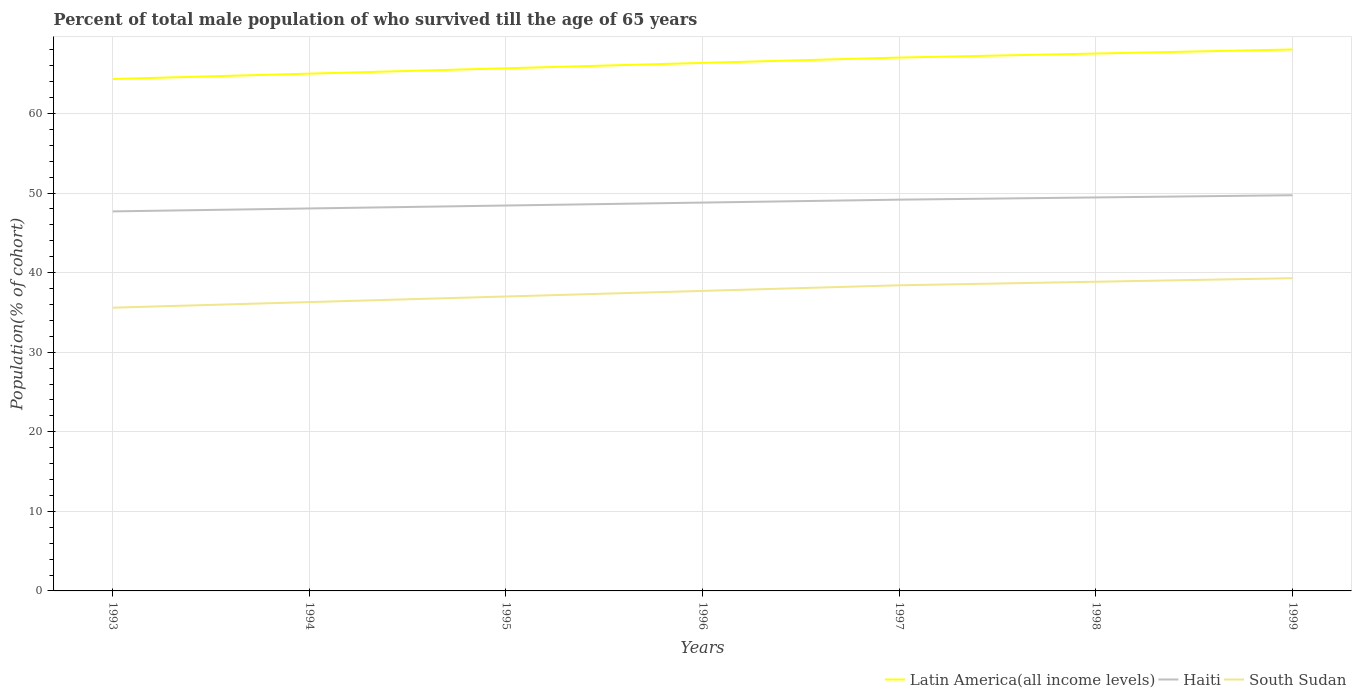How many different coloured lines are there?
Your response must be concise. 3. Across all years, what is the maximum percentage of total male population who survived till the age of 65 years in South Sudan?
Provide a short and direct response. 35.59. In which year was the percentage of total male population who survived till the age of 65 years in South Sudan maximum?
Provide a short and direct response. 1993. What is the total percentage of total male population who survived till the age of 65 years in Haiti in the graph?
Keep it short and to the point. -0.74. What is the difference between the highest and the second highest percentage of total male population who survived till the age of 65 years in Latin America(all income levels)?
Your answer should be very brief. 3.71. What is the difference between the highest and the lowest percentage of total male population who survived till the age of 65 years in Haiti?
Provide a short and direct response. 4. How many lines are there?
Provide a succinct answer. 3. Does the graph contain any zero values?
Your answer should be very brief. No. Does the graph contain grids?
Offer a terse response. Yes. How many legend labels are there?
Provide a succinct answer. 3. How are the legend labels stacked?
Provide a short and direct response. Horizontal. What is the title of the graph?
Your answer should be compact. Percent of total male population of who survived till the age of 65 years. What is the label or title of the X-axis?
Provide a succinct answer. Years. What is the label or title of the Y-axis?
Provide a short and direct response. Population(% of cohort). What is the Population(% of cohort) in Latin America(all income levels) in 1993?
Make the answer very short. 64.33. What is the Population(% of cohort) of Haiti in 1993?
Your response must be concise. 47.69. What is the Population(% of cohort) of South Sudan in 1993?
Ensure brevity in your answer.  35.59. What is the Population(% of cohort) of Latin America(all income levels) in 1994?
Make the answer very short. 65.01. What is the Population(% of cohort) of Haiti in 1994?
Ensure brevity in your answer.  48.06. What is the Population(% of cohort) of South Sudan in 1994?
Your response must be concise. 36.3. What is the Population(% of cohort) of Latin America(all income levels) in 1995?
Provide a short and direct response. 65.68. What is the Population(% of cohort) of Haiti in 1995?
Your answer should be compact. 48.43. What is the Population(% of cohort) in South Sudan in 1995?
Keep it short and to the point. 37. What is the Population(% of cohort) of Latin America(all income levels) in 1996?
Your answer should be compact. 66.35. What is the Population(% of cohort) of Haiti in 1996?
Make the answer very short. 48.8. What is the Population(% of cohort) in South Sudan in 1996?
Ensure brevity in your answer.  37.7. What is the Population(% of cohort) in Latin America(all income levels) in 1997?
Your answer should be compact. 67.02. What is the Population(% of cohort) of Haiti in 1997?
Offer a very short reply. 49.17. What is the Population(% of cohort) in South Sudan in 1997?
Offer a very short reply. 38.41. What is the Population(% of cohort) in Latin America(all income levels) in 1998?
Provide a short and direct response. 67.53. What is the Population(% of cohort) in Haiti in 1998?
Make the answer very short. 49.45. What is the Population(% of cohort) of South Sudan in 1998?
Provide a short and direct response. 38.85. What is the Population(% of cohort) of Latin America(all income levels) in 1999?
Provide a succinct answer. 68.04. What is the Population(% of cohort) in Haiti in 1999?
Ensure brevity in your answer.  49.73. What is the Population(% of cohort) in South Sudan in 1999?
Your answer should be very brief. 39.3. Across all years, what is the maximum Population(% of cohort) in Latin America(all income levels)?
Make the answer very short. 68.04. Across all years, what is the maximum Population(% of cohort) in Haiti?
Your response must be concise. 49.73. Across all years, what is the maximum Population(% of cohort) in South Sudan?
Keep it short and to the point. 39.3. Across all years, what is the minimum Population(% of cohort) in Latin America(all income levels)?
Offer a very short reply. 64.33. Across all years, what is the minimum Population(% of cohort) in Haiti?
Provide a succinct answer. 47.69. Across all years, what is the minimum Population(% of cohort) in South Sudan?
Offer a terse response. 35.59. What is the total Population(% of cohort) of Latin America(all income levels) in the graph?
Provide a succinct answer. 463.97. What is the total Population(% of cohort) in Haiti in the graph?
Offer a terse response. 341.34. What is the total Population(% of cohort) of South Sudan in the graph?
Your response must be concise. 263.16. What is the difference between the Population(% of cohort) of Latin America(all income levels) in 1993 and that in 1994?
Give a very brief answer. -0.68. What is the difference between the Population(% of cohort) in Haiti in 1993 and that in 1994?
Give a very brief answer. -0.37. What is the difference between the Population(% of cohort) of South Sudan in 1993 and that in 1994?
Your response must be concise. -0.7. What is the difference between the Population(% of cohort) of Latin America(all income levels) in 1993 and that in 1995?
Your response must be concise. -1.35. What is the difference between the Population(% of cohort) in Haiti in 1993 and that in 1995?
Your response must be concise. -0.74. What is the difference between the Population(% of cohort) in South Sudan in 1993 and that in 1995?
Provide a short and direct response. -1.41. What is the difference between the Population(% of cohort) in Latin America(all income levels) in 1993 and that in 1996?
Your answer should be very brief. -2.02. What is the difference between the Population(% of cohort) of Haiti in 1993 and that in 1996?
Provide a succinct answer. -1.11. What is the difference between the Population(% of cohort) in South Sudan in 1993 and that in 1996?
Your answer should be very brief. -2.11. What is the difference between the Population(% of cohort) in Latin America(all income levels) in 1993 and that in 1997?
Provide a succinct answer. -2.7. What is the difference between the Population(% of cohort) of Haiti in 1993 and that in 1997?
Keep it short and to the point. -1.48. What is the difference between the Population(% of cohort) in South Sudan in 1993 and that in 1997?
Provide a succinct answer. -2.81. What is the difference between the Population(% of cohort) of Latin America(all income levels) in 1993 and that in 1998?
Make the answer very short. -3.2. What is the difference between the Population(% of cohort) in Haiti in 1993 and that in 1998?
Offer a very short reply. -1.75. What is the difference between the Population(% of cohort) of South Sudan in 1993 and that in 1998?
Make the answer very short. -3.26. What is the difference between the Population(% of cohort) of Latin America(all income levels) in 1993 and that in 1999?
Your answer should be compact. -3.71. What is the difference between the Population(% of cohort) of Haiti in 1993 and that in 1999?
Give a very brief answer. -2.03. What is the difference between the Population(% of cohort) of South Sudan in 1993 and that in 1999?
Offer a terse response. -3.71. What is the difference between the Population(% of cohort) in Latin America(all income levels) in 1994 and that in 1995?
Your answer should be compact. -0.67. What is the difference between the Population(% of cohort) of Haiti in 1994 and that in 1995?
Provide a succinct answer. -0.37. What is the difference between the Population(% of cohort) of South Sudan in 1994 and that in 1995?
Your response must be concise. -0.7. What is the difference between the Population(% of cohort) in Latin America(all income levels) in 1994 and that in 1996?
Provide a succinct answer. -1.35. What is the difference between the Population(% of cohort) in Haiti in 1994 and that in 1996?
Your answer should be very brief. -0.74. What is the difference between the Population(% of cohort) of South Sudan in 1994 and that in 1996?
Your response must be concise. -1.41. What is the difference between the Population(% of cohort) of Latin America(all income levels) in 1994 and that in 1997?
Your answer should be very brief. -2.02. What is the difference between the Population(% of cohort) of Haiti in 1994 and that in 1997?
Ensure brevity in your answer.  -1.11. What is the difference between the Population(% of cohort) of South Sudan in 1994 and that in 1997?
Keep it short and to the point. -2.11. What is the difference between the Population(% of cohort) of Latin America(all income levels) in 1994 and that in 1998?
Offer a very short reply. -2.53. What is the difference between the Population(% of cohort) of Haiti in 1994 and that in 1998?
Your response must be concise. -1.38. What is the difference between the Population(% of cohort) of South Sudan in 1994 and that in 1998?
Your answer should be compact. -2.56. What is the difference between the Population(% of cohort) of Latin America(all income levels) in 1994 and that in 1999?
Provide a succinct answer. -3.03. What is the difference between the Population(% of cohort) in Haiti in 1994 and that in 1999?
Offer a terse response. -1.66. What is the difference between the Population(% of cohort) of South Sudan in 1994 and that in 1999?
Your response must be concise. -3. What is the difference between the Population(% of cohort) of Latin America(all income levels) in 1995 and that in 1996?
Your answer should be very brief. -0.67. What is the difference between the Population(% of cohort) of Haiti in 1995 and that in 1996?
Your answer should be compact. -0.37. What is the difference between the Population(% of cohort) in South Sudan in 1995 and that in 1996?
Your response must be concise. -0.7. What is the difference between the Population(% of cohort) in Latin America(all income levels) in 1995 and that in 1997?
Offer a very short reply. -1.35. What is the difference between the Population(% of cohort) in Haiti in 1995 and that in 1997?
Your response must be concise. -0.74. What is the difference between the Population(% of cohort) of South Sudan in 1995 and that in 1997?
Give a very brief answer. -1.41. What is the difference between the Population(% of cohort) in Latin America(all income levels) in 1995 and that in 1998?
Offer a very short reply. -1.85. What is the difference between the Population(% of cohort) in Haiti in 1995 and that in 1998?
Keep it short and to the point. -1.02. What is the difference between the Population(% of cohort) of South Sudan in 1995 and that in 1998?
Make the answer very short. -1.85. What is the difference between the Population(% of cohort) of Latin America(all income levels) in 1995 and that in 1999?
Provide a succinct answer. -2.36. What is the difference between the Population(% of cohort) of Haiti in 1995 and that in 1999?
Give a very brief answer. -1.29. What is the difference between the Population(% of cohort) of South Sudan in 1995 and that in 1999?
Keep it short and to the point. -2.3. What is the difference between the Population(% of cohort) in Latin America(all income levels) in 1996 and that in 1997?
Provide a succinct answer. -0.67. What is the difference between the Population(% of cohort) of Haiti in 1996 and that in 1997?
Offer a very short reply. -0.37. What is the difference between the Population(% of cohort) of South Sudan in 1996 and that in 1997?
Keep it short and to the point. -0.7. What is the difference between the Population(% of cohort) of Latin America(all income levels) in 1996 and that in 1998?
Provide a succinct answer. -1.18. What is the difference between the Population(% of cohort) of Haiti in 1996 and that in 1998?
Keep it short and to the point. -0.65. What is the difference between the Population(% of cohort) in South Sudan in 1996 and that in 1998?
Offer a very short reply. -1.15. What is the difference between the Population(% of cohort) of Latin America(all income levels) in 1996 and that in 1999?
Give a very brief answer. -1.69. What is the difference between the Population(% of cohort) of Haiti in 1996 and that in 1999?
Provide a short and direct response. -0.93. What is the difference between the Population(% of cohort) of South Sudan in 1996 and that in 1999?
Offer a terse response. -1.6. What is the difference between the Population(% of cohort) of Latin America(all income levels) in 1997 and that in 1998?
Offer a terse response. -0.51. What is the difference between the Population(% of cohort) in Haiti in 1997 and that in 1998?
Keep it short and to the point. -0.28. What is the difference between the Population(% of cohort) in South Sudan in 1997 and that in 1998?
Offer a very short reply. -0.45. What is the difference between the Population(% of cohort) in Latin America(all income levels) in 1997 and that in 1999?
Keep it short and to the point. -1.02. What is the difference between the Population(% of cohort) in Haiti in 1997 and that in 1999?
Your answer should be very brief. -0.56. What is the difference between the Population(% of cohort) of South Sudan in 1997 and that in 1999?
Your response must be concise. -0.89. What is the difference between the Population(% of cohort) in Latin America(all income levels) in 1998 and that in 1999?
Make the answer very short. -0.51. What is the difference between the Population(% of cohort) in Haiti in 1998 and that in 1999?
Give a very brief answer. -0.28. What is the difference between the Population(% of cohort) in South Sudan in 1998 and that in 1999?
Keep it short and to the point. -0.45. What is the difference between the Population(% of cohort) in Latin America(all income levels) in 1993 and the Population(% of cohort) in Haiti in 1994?
Give a very brief answer. 16.27. What is the difference between the Population(% of cohort) in Latin America(all income levels) in 1993 and the Population(% of cohort) in South Sudan in 1994?
Offer a very short reply. 28.03. What is the difference between the Population(% of cohort) in Haiti in 1993 and the Population(% of cohort) in South Sudan in 1994?
Keep it short and to the point. 11.4. What is the difference between the Population(% of cohort) of Latin America(all income levels) in 1993 and the Population(% of cohort) of Haiti in 1995?
Offer a very short reply. 15.9. What is the difference between the Population(% of cohort) in Latin America(all income levels) in 1993 and the Population(% of cohort) in South Sudan in 1995?
Make the answer very short. 27.33. What is the difference between the Population(% of cohort) in Haiti in 1993 and the Population(% of cohort) in South Sudan in 1995?
Offer a very short reply. 10.69. What is the difference between the Population(% of cohort) of Latin America(all income levels) in 1993 and the Population(% of cohort) of Haiti in 1996?
Ensure brevity in your answer.  15.53. What is the difference between the Population(% of cohort) in Latin America(all income levels) in 1993 and the Population(% of cohort) in South Sudan in 1996?
Your response must be concise. 26.62. What is the difference between the Population(% of cohort) of Haiti in 1993 and the Population(% of cohort) of South Sudan in 1996?
Give a very brief answer. 9.99. What is the difference between the Population(% of cohort) in Latin America(all income levels) in 1993 and the Population(% of cohort) in Haiti in 1997?
Your response must be concise. 15.16. What is the difference between the Population(% of cohort) of Latin America(all income levels) in 1993 and the Population(% of cohort) of South Sudan in 1997?
Provide a short and direct response. 25.92. What is the difference between the Population(% of cohort) of Haiti in 1993 and the Population(% of cohort) of South Sudan in 1997?
Your answer should be compact. 9.29. What is the difference between the Population(% of cohort) of Latin America(all income levels) in 1993 and the Population(% of cohort) of Haiti in 1998?
Ensure brevity in your answer.  14.88. What is the difference between the Population(% of cohort) in Latin America(all income levels) in 1993 and the Population(% of cohort) in South Sudan in 1998?
Ensure brevity in your answer.  25.47. What is the difference between the Population(% of cohort) of Haiti in 1993 and the Population(% of cohort) of South Sudan in 1998?
Provide a succinct answer. 8.84. What is the difference between the Population(% of cohort) of Latin America(all income levels) in 1993 and the Population(% of cohort) of Haiti in 1999?
Your response must be concise. 14.6. What is the difference between the Population(% of cohort) of Latin America(all income levels) in 1993 and the Population(% of cohort) of South Sudan in 1999?
Offer a very short reply. 25.03. What is the difference between the Population(% of cohort) of Haiti in 1993 and the Population(% of cohort) of South Sudan in 1999?
Ensure brevity in your answer.  8.39. What is the difference between the Population(% of cohort) of Latin America(all income levels) in 1994 and the Population(% of cohort) of Haiti in 1995?
Make the answer very short. 16.57. What is the difference between the Population(% of cohort) of Latin America(all income levels) in 1994 and the Population(% of cohort) of South Sudan in 1995?
Make the answer very short. 28. What is the difference between the Population(% of cohort) of Haiti in 1994 and the Population(% of cohort) of South Sudan in 1995?
Your answer should be very brief. 11.06. What is the difference between the Population(% of cohort) of Latin America(all income levels) in 1994 and the Population(% of cohort) of Haiti in 1996?
Keep it short and to the point. 16.2. What is the difference between the Population(% of cohort) in Latin America(all income levels) in 1994 and the Population(% of cohort) in South Sudan in 1996?
Give a very brief answer. 27.3. What is the difference between the Population(% of cohort) in Haiti in 1994 and the Population(% of cohort) in South Sudan in 1996?
Your response must be concise. 10.36. What is the difference between the Population(% of cohort) of Latin America(all income levels) in 1994 and the Population(% of cohort) of Haiti in 1997?
Provide a succinct answer. 15.84. What is the difference between the Population(% of cohort) in Latin America(all income levels) in 1994 and the Population(% of cohort) in South Sudan in 1997?
Make the answer very short. 26.6. What is the difference between the Population(% of cohort) in Haiti in 1994 and the Population(% of cohort) in South Sudan in 1997?
Offer a very short reply. 9.66. What is the difference between the Population(% of cohort) of Latin America(all income levels) in 1994 and the Population(% of cohort) of Haiti in 1998?
Offer a very short reply. 15.56. What is the difference between the Population(% of cohort) in Latin America(all income levels) in 1994 and the Population(% of cohort) in South Sudan in 1998?
Keep it short and to the point. 26.15. What is the difference between the Population(% of cohort) in Haiti in 1994 and the Population(% of cohort) in South Sudan in 1998?
Make the answer very short. 9.21. What is the difference between the Population(% of cohort) of Latin America(all income levels) in 1994 and the Population(% of cohort) of Haiti in 1999?
Give a very brief answer. 15.28. What is the difference between the Population(% of cohort) in Latin America(all income levels) in 1994 and the Population(% of cohort) in South Sudan in 1999?
Give a very brief answer. 25.7. What is the difference between the Population(% of cohort) in Haiti in 1994 and the Population(% of cohort) in South Sudan in 1999?
Give a very brief answer. 8.76. What is the difference between the Population(% of cohort) of Latin America(all income levels) in 1995 and the Population(% of cohort) of Haiti in 1996?
Your answer should be compact. 16.88. What is the difference between the Population(% of cohort) in Latin America(all income levels) in 1995 and the Population(% of cohort) in South Sudan in 1996?
Your response must be concise. 27.97. What is the difference between the Population(% of cohort) in Haiti in 1995 and the Population(% of cohort) in South Sudan in 1996?
Make the answer very short. 10.73. What is the difference between the Population(% of cohort) in Latin America(all income levels) in 1995 and the Population(% of cohort) in Haiti in 1997?
Give a very brief answer. 16.51. What is the difference between the Population(% of cohort) in Latin America(all income levels) in 1995 and the Population(% of cohort) in South Sudan in 1997?
Provide a succinct answer. 27.27. What is the difference between the Population(% of cohort) of Haiti in 1995 and the Population(% of cohort) of South Sudan in 1997?
Your answer should be compact. 10.02. What is the difference between the Population(% of cohort) in Latin America(all income levels) in 1995 and the Population(% of cohort) in Haiti in 1998?
Your response must be concise. 16.23. What is the difference between the Population(% of cohort) of Latin America(all income levels) in 1995 and the Population(% of cohort) of South Sudan in 1998?
Your answer should be compact. 26.82. What is the difference between the Population(% of cohort) of Haiti in 1995 and the Population(% of cohort) of South Sudan in 1998?
Keep it short and to the point. 9.58. What is the difference between the Population(% of cohort) of Latin America(all income levels) in 1995 and the Population(% of cohort) of Haiti in 1999?
Your answer should be very brief. 15.95. What is the difference between the Population(% of cohort) of Latin America(all income levels) in 1995 and the Population(% of cohort) of South Sudan in 1999?
Offer a terse response. 26.38. What is the difference between the Population(% of cohort) of Haiti in 1995 and the Population(% of cohort) of South Sudan in 1999?
Ensure brevity in your answer.  9.13. What is the difference between the Population(% of cohort) in Latin America(all income levels) in 1996 and the Population(% of cohort) in Haiti in 1997?
Give a very brief answer. 17.18. What is the difference between the Population(% of cohort) of Latin America(all income levels) in 1996 and the Population(% of cohort) of South Sudan in 1997?
Offer a very short reply. 27.95. What is the difference between the Population(% of cohort) in Haiti in 1996 and the Population(% of cohort) in South Sudan in 1997?
Keep it short and to the point. 10.39. What is the difference between the Population(% of cohort) in Latin America(all income levels) in 1996 and the Population(% of cohort) in Haiti in 1998?
Your answer should be very brief. 16.9. What is the difference between the Population(% of cohort) of Latin America(all income levels) in 1996 and the Population(% of cohort) of South Sudan in 1998?
Your answer should be very brief. 27.5. What is the difference between the Population(% of cohort) in Haiti in 1996 and the Population(% of cohort) in South Sudan in 1998?
Provide a short and direct response. 9.95. What is the difference between the Population(% of cohort) of Latin America(all income levels) in 1996 and the Population(% of cohort) of Haiti in 1999?
Keep it short and to the point. 16.63. What is the difference between the Population(% of cohort) in Latin America(all income levels) in 1996 and the Population(% of cohort) in South Sudan in 1999?
Your answer should be compact. 27.05. What is the difference between the Population(% of cohort) in Haiti in 1996 and the Population(% of cohort) in South Sudan in 1999?
Keep it short and to the point. 9.5. What is the difference between the Population(% of cohort) of Latin America(all income levels) in 1997 and the Population(% of cohort) of Haiti in 1998?
Provide a succinct answer. 17.58. What is the difference between the Population(% of cohort) in Latin America(all income levels) in 1997 and the Population(% of cohort) in South Sudan in 1998?
Ensure brevity in your answer.  28.17. What is the difference between the Population(% of cohort) in Haiti in 1997 and the Population(% of cohort) in South Sudan in 1998?
Keep it short and to the point. 10.32. What is the difference between the Population(% of cohort) in Latin America(all income levels) in 1997 and the Population(% of cohort) in Haiti in 1999?
Give a very brief answer. 17.3. What is the difference between the Population(% of cohort) of Latin America(all income levels) in 1997 and the Population(% of cohort) of South Sudan in 1999?
Offer a very short reply. 27.72. What is the difference between the Population(% of cohort) in Haiti in 1997 and the Population(% of cohort) in South Sudan in 1999?
Offer a terse response. 9.87. What is the difference between the Population(% of cohort) of Latin America(all income levels) in 1998 and the Population(% of cohort) of Haiti in 1999?
Your answer should be very brief. 17.81. What is the difference between the Population(% of cohort) of Latin America(all income levels) in 1998 and the Population(% of cohort) of South Sudan in 1999?
Your response must be concise. 28.23. What is the difference between the Population(% of cohort) of Haiti in 1998 and the Population(% of cohort) of South Sudan in 1999?
Offer a terse response. 10.15. What is the average Population(% of cohort) of Latin America(all income levels) per year?
Your response must be concise. 66.28. What is the average Population(% of cohort) of Haiti per year?
Provide a short and direct response. 48.76. What is the average Population(% of cohort) of South Sudan per year?
Offer a terse response. 37.59. In the year 1993, what is the difference between the Population(% of cohort) in Latin America(all income levels) and Population(% of cohort) in Haiti?
Offer a very short reply. 16.63. In the year 1993, what is the difference between the Population(% of cohort) of Latin America(all income levels) and Population(% of cohort) of South Sudan?
Keep it short and to the point. 28.74. In the year 1993, what is the difference between the Population(% of cohort) of Haiti and Population(% of cohort) of South Sudan?
Provide a succinct answer. 12.1. In the year 1994, what is the difference between the Population(% of cohort) in Latin America(all income levels) and Population(% of cohort) in Haiti?
Your response must be concise. 16.94. In the year 1994, what is the difference between the Population(% of cohort) of Latin America(all income levels) and Population(% of cohort) of South Sudan?
Offer a terse response. 28.71. In the year 1994, what is the difference between the Population(% of cohort) in Haiti and Population(% of cohort) in South Sudan?
Offer a very short reply. 11.77. In the year 1995, what is the difference between the Population(% of cohort) of Latin America(all income levels) and Population(% of cohort) of Haiti?
Keep it short and to the point. 17.25. In the year 1995, what is the difference between the Population(% of cohort) in Latin America(all income levels) and Population(% of cohort) in South Sudan?
Your answer should be very brief. 28.68. In the year 1995, what is the difference between the Population(% of cohort) of Haiti and Population(% of cohort) of South Sudan?
Provide a short and direct response. 11.43. In the year 1996, what is the difference between the Population(% of cohort) of Latin America(all income levels) and Population(% of cohort) of Haiti?
Offer a very short reply. 17.55. In the year 1996, what is the difference between the Population(% of cohort) in Latin America(all income levels) and Population(% of cohort) in South Sudan?
Your answer should be compact. 28.65. In the year 1996, what is the difference between the Population(% of cohort) of Haiti and Population(% of cohort) of South Sudan?
Give a very brief answer. 11.1. In the year 1997, what is the difference between the Population(% of cohort) in Latin America(all income levels) and Population(% of cohort) in Haiti?
Offer a very short reply. 17.85. In the year 1997, what is the difference between the Population(% of cohort) in Latin America(all income levels) and Population(% of cohort) in South Sudan?
Your response must be concise. 28.62. In the year 1997, what is the difference between the Population(% of cohort) in Haiti and Population(% of cohort) in South Sudan?
Ensure brevity in your answer.  10.76. In the year 1998, what is the difference between the Population(% of cohort) in Latin America(all income levels) and Population(% of cohort) in Haiti?
Make the answer very short. 18.08. In the year 1998, what is the difference between the Population(% of cohort) in Latin America(all income levels) and Population(% of cohort) in South Sudan?
Make the answer very short. 28.68. In the year 1998, what is the difference between the Population(% of cohort) in Haiti and Population(% of cohort) in South Sudan?
Provide a succinct answer. 10.59. In the year 1999, what is the difference between the Population(% of cohort) of Latin America(all income levels) and Population(% of cohort) of Haiti?
Your answer should be compact. 18.31. In the year 1999, what is the difference between the Population(% of cohort) of Latin America(all income levels) and Population(% of cohort) of South Sudan?
Offer a very short reply. 28.74. In the year 1999, what is the difference between the Population(% of cohort) of Haiti and Population(% of cohort) of South Sudan?
Your answer should be very brief. 10.43. What is the ratio of the Population(% of cohort) of South Sudan in 1993 to that in 1994?
Offer a very short reply. 0.98. What is the ratio of the Population(% of cohort) in Latin America(all income levels) in 1993 to that in 1995?
Your answer should be very brief. 0.98. What is the ratio of the Population(% of cohort) of South Sudan in 1993 to that in 1995?
Make the answer very short. 0.96. What is the ratio of the Population(% of cohort) in Latin America(all income levels) in 1993 to that in 1996?
Provide a succinct answer. 0.97. What is the ratio of the Population(% of cohort) of Haiti in 1993 to that in 1996?
Your answer should be very brief. 0.98. What is the ratio of the Population(% of cohort) of South Sudan in 1993 to that in 1996?
Provide a succinct answer. 0.94. What is the ratio of the Population(% of cohort) of Latin America(all income levels) in 1993 to that in 1997?
Your answer should be very brief. 0.96. What is the ratio of the Population(% of cohort) in South Sudan in 1993 to that in 1997?
Offer a terse response. 0.93. What is the ratio of the Population(% of cohort) of Latin America(all income levels) in 1993 to that in 1998?
Make the answer very short. 0.95. What is the ratio of the Population(% of cohort) of Haiti in 1993 to that in 1998?
Offer a very short reply. 0.96. What is the ratio of the Population(% of cohort) in South Sudan in 1993 to that in 1998?
Your answer should be compact. 0.92. What is the ratio of the Population(% of cohort) in Latin America(all income levels) in 1993 to that in 1999?
Provide a short and direct response. 0.95. What is the ratio of the Population(% of cohort) of Haiti in 1993 to that in 1999?
Offer a very short reply. 0.96. What is the ratio of the Population(% of cohort) in South Sudan in 1993 to that in 1999?
Give a very brief answer. 0.91. What is the ratio of the Population(% of cohort) of Latin America(all income levels) in 1994 to that in 1995?
Give a very brief answer. 0.99. What is the ratio of the Population(% of cohort) of South Sudan in 1994 to that in 1995?
Your answer should be very brief. 0.98. What is the ratio of the Population(% of cohort) of Latin America(all income levels) in 1994 to that in 1996?
Your response must be concise. 0.98. What is the ratio of the Population(% of cohort) of Haiti in 1994 to that in 1996?
Offer a very short reply. 0.98. What is the ratio of the Population(% of cohort) in South Sudan in 1994 to that in 1996?
Your answer should be compact. 0.96. What is the ratio of the Population(% of cohort) of Latin America(all income levels) in 1994 to that in 1997?
Give a very brief answer. 0.97. What is the ratio of the Population(% of cohort) in Haiti in 1994 to that in 1997?
Offer a terse response. 0.98. What is the ratio of the Population(% of cohort) of South Sudan in 1994 to that in 1997?
Provide a succinct answer. 0.94. What is the ratio of the Population(% of cohort) in Latin America(all income levels) in 1994 to that in 1998?
Your response must be concise. 0.96. What is the ratio of the Population(% of cohort) of Haiti in 1994 to that in 1998?
Provide a short and direct response. 0.97. What is the ratio of the Population(% of cohort) in South Sudan in 1994 to that in 1998?
Offer a terse response. 0.93. What is the ratio of the Population(% of cohort) of Latin America(all income levels) in 1994 to that in 1999?
Give a very brief answer. 0.96. What is the ratio of the Population(% of cohort) in Haiti in 1994 to that in 1999?
Keep it short and to the point. 0.97. What is the ratio of the Population(% of cohort) in South Sudan in 1994 to that in 1999?
Offer a very short reply. 0.92. What is the ratio of the Population(% of cohort) in Latin America(all income levels) in 1995 to that in 1996?
Provide a succinct answer. 0.99. What is the ratio of the Population(% of cohort) in South Sudan in 1995 to that in 1996?
Ensure brevity in your answer.  0.98. What is the ratio of the Population(% of cohort) in Latin America(all income levels) in 1995 to that in 1997?
Give a very brief answer. 0.98. What is the ratio of the Population(% of cohort) of South Sudan in 1995 to that in 1997?
Your response must be concise. 0.96. What is the ratio of the Population(% of cohort) of Latin America(all income levels) in 1995 to that in 1998?
Provide a succinct answer. 0.97. What is the ratio of the Population(% of cohort) in Haiti in 1995 to that in 1998?
Make the answer very short. 0.98. What is the ratio of the Population(% of cohort) of South Sudan in 1995 to that in 1998?
Keep it short and to the point. 0.95. What is the ratio of the Population(% of cohort) in Latin America(all income levels) in 1995 to that in 1999?
Provide a short and direct response. 0.97. What is the ratio of the Population(% of cohort) of South Sudan in 1995 to that in 1999?
Keep it short and to the point. 0.94. What is the ratio of the Population(% of cohort) in Latin America(all income levels) in 1996 to that in 1997?
Your answer should be compact. 0.99. What is the ratio of the Population(% of cohort) in Haiti in 1996 to that in 1997?
Ensure brevity in your answer.  0.99. What is the ratio of the Population(% of cohort) in South Sudan in 1996 to that in 1997?
Your answer should be compact. 0.98. What is the ratio of the Population(% of cohort) in Latin America(all income levels) in 1996 to that in 1998?
Offer a very short reply. 0.98. What is the ratio of the Population(% of cohort) in Haiti in 1996 to that in 1998?
Make the answer very short. 0.99. What is the ratio of the Population(% of cohort) in South Sudan in 1996 to that in 1998?
Make the answer very short. 0.97. What is the ratio of the Population(% of cohort) of Latin America(all income levels) in 1996 to that in 1999?
Make the answer very short. 0.98. What is the ratio of the Population(% of cohort) of Haiti in 1996 to that in 1999?
Offer a terse response. 0.98. What is the ratio of the Population(% of cohort) of South Sudan in 1996 to that in 1999?
Ensure brevity in your answer.  0.96. What is the ratio of the Population(% of cohort) in Latin America(all income levels) in 1997 to that in 1998?
Your response must be concise. 0.99. What is the ratio of the Population(% of cohort) in South Sudan in 1997 to that in 1998?
Your answer should be compact. 0.99. What is the ratio of the Population(% of cohort) in Latin America(all income levels) in 1997 to that in 1999?
Keep it short and to the point. 0.99. What is the ratio of the Population(% of cohort) of Haiti in 1997 to that in 1999?
Make the answer very short. 0.99. What is the ratio of the Population(% of cohort) of South Sudan in 1997 to that in 1999?
Offer a terse response. 0.98. What is the ratio of the Population(% of cohort) in Latin America(all income levels) in 1998 to that in 1999?
Offer a terse response. 0.99. What is the difference between the highest and the second highest Population(% of cohort) in Latin America(all income levels)?
Provide a short and direct response. 0.51. What is the difference between the highest and the second highest Population(% of cohort) of Haiti?
Your response must be concise. 0.28. What is the difference between the highest and the second highest Population(% of cohort) in South Sudan?
Provide a short and direct response. 0.45. What is the difference between the highest and the lowest Population(% of cohort) in Latin America(all income levels)?
Make the answer very short. 3.71. What is the difference between the highest and the lowest Population(% of cohort) in Haiti?
Give a very brief answer. 2.03. What is the difference between the highest and the lowest Population(% of cohort) in South Sudan?
Provide a short and direct response. 3.71. 